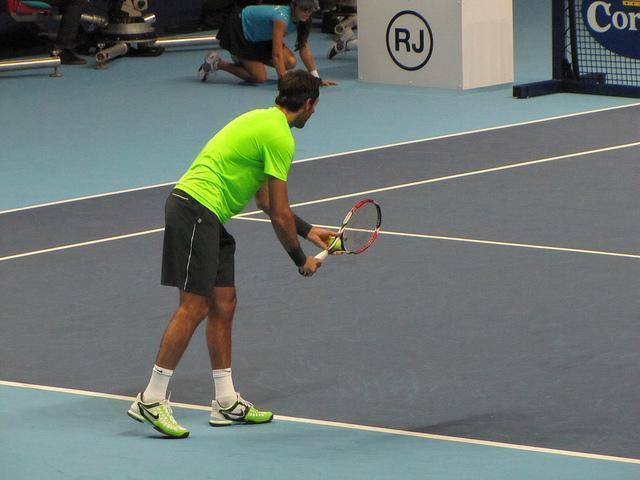What is the job of the girl who is knelt down in the front of the picture?
Indicate the correct response by choosing from the four available options to answer the question.
Options: Collect ball, spectator, referee, camera crew. Collect ball. 